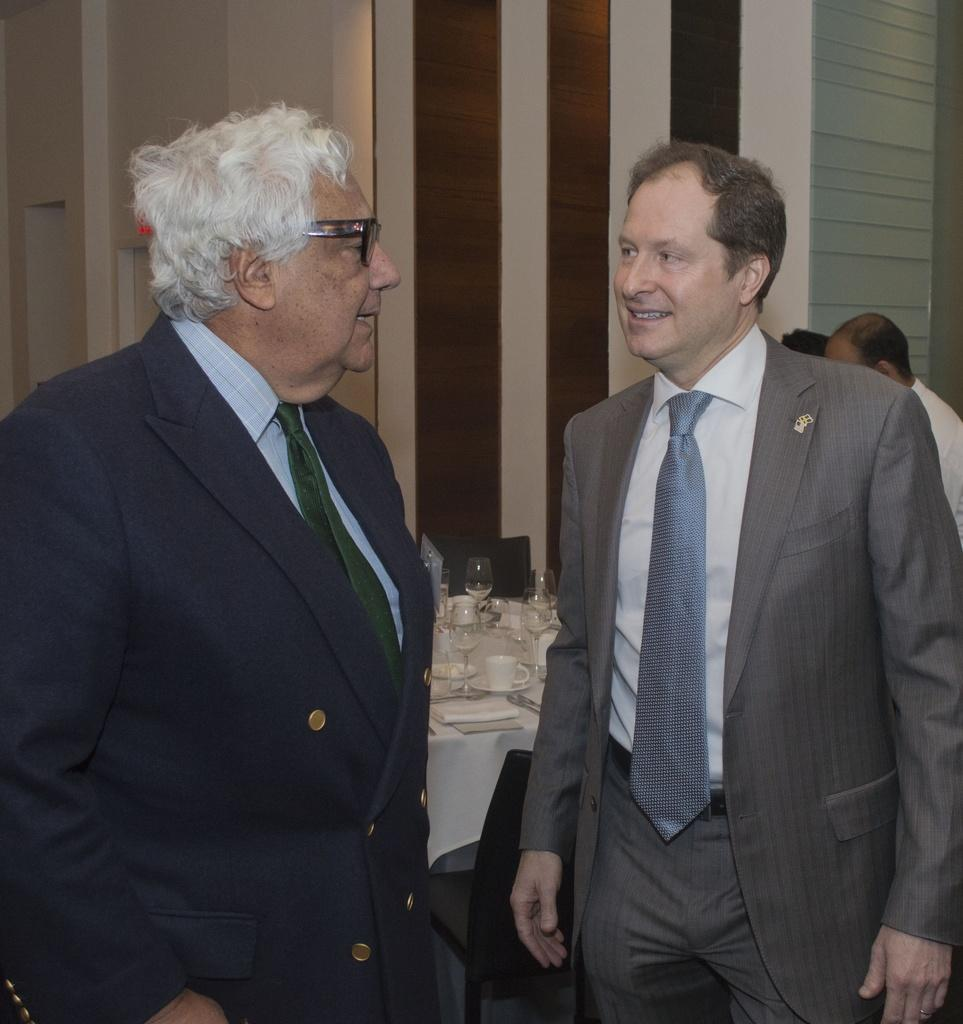Who or what is present in the image? There are people in the image. What is on the table in the image? There is a table covered with a cloth, and glasses and cups are present on the table. What type of furniture is visible in the image? There are chairs in the image. What can be seen on the wall in the image? The wall is visible in the image. What is the price of the sand in the image? There is no sand present in the image, so it is not possible to determine the price of any sand. 